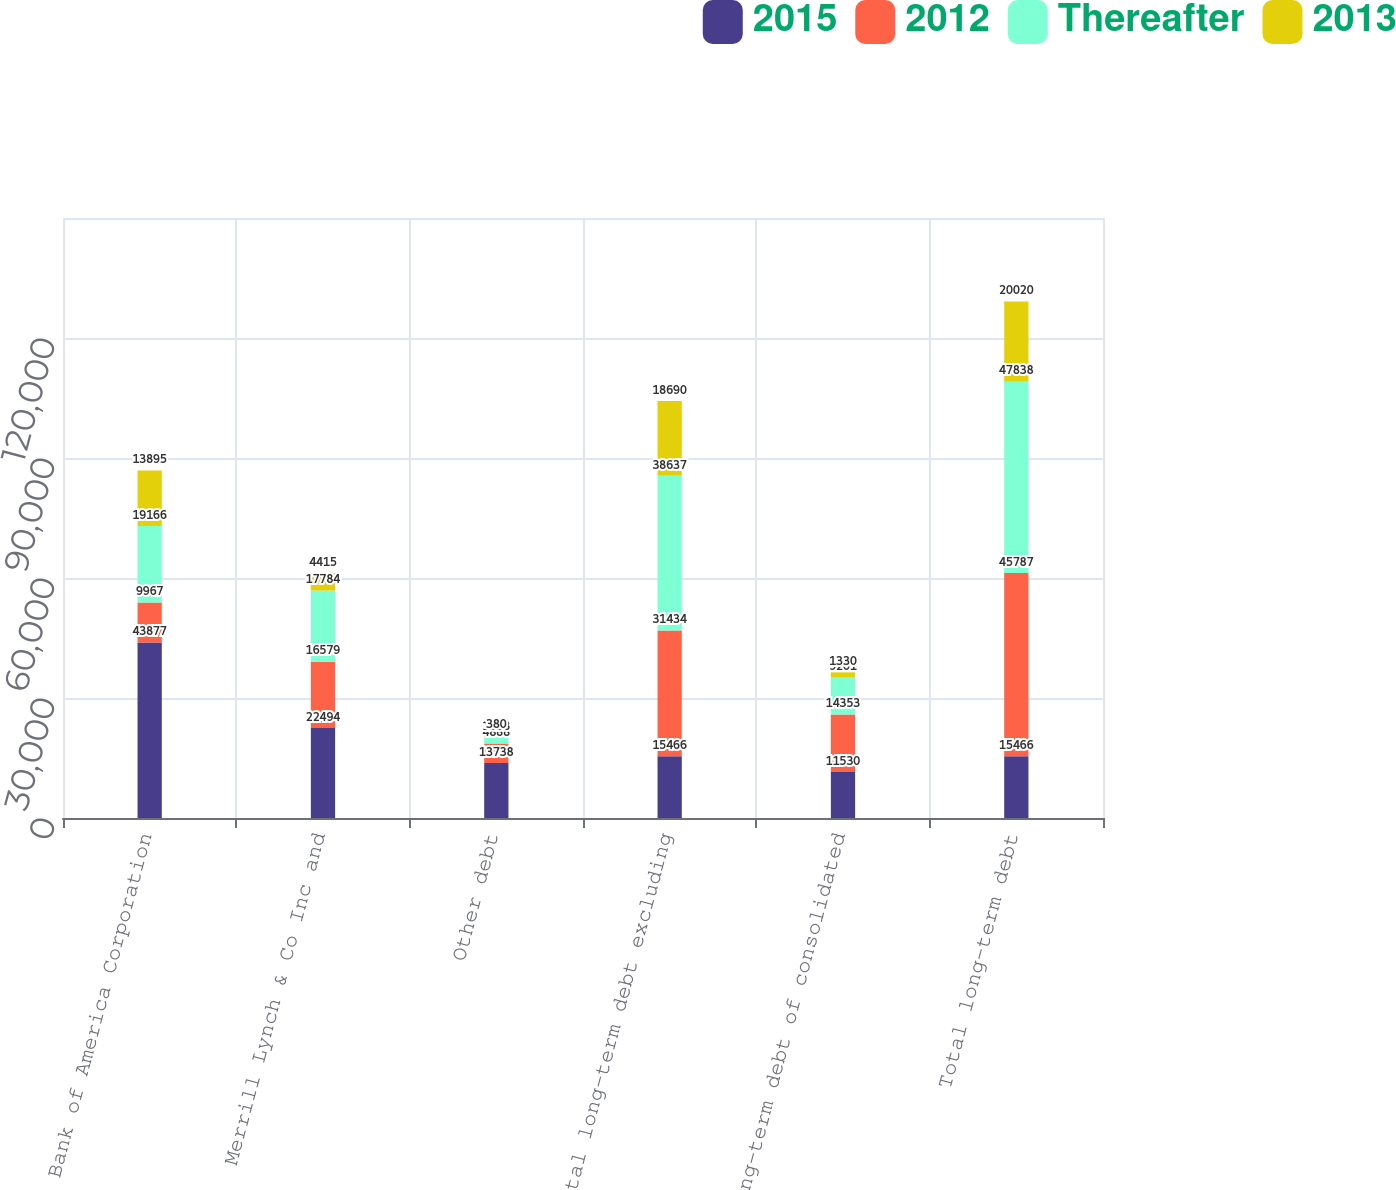Convert chart. <chart><loc_0><loc_0><loc_500><loc_500><stacked_bar_chart><ecel><fcel>Bank of America Corporation<fcel>Merrill Lynch & Co Inc and<fcel>Other debt<fcel>Total long-term debt excluding<fcel>Long-term debt of consolidated<fcel>Total long-term debt<nl><fcel>2015<fcel>43877<fcel>22494<fcel>13738<fcel>15466<fcel>11530<fcel>15466<nl><fcel>2012<fcel>9967<fcel>16579<fcel>4888<fcel>31434<fcel>14353<fcel>45787<nl><fcel>Thereafter<fcel>19166<fcel>17784<fcel>1658<fcel>38637<fcel>9201<fcel>47838<nl><fcel>2013<fcel>13895<fcel>4415<fcel>380<fcel>18690<fcel>1330<fcel>20020<nl></chart> 